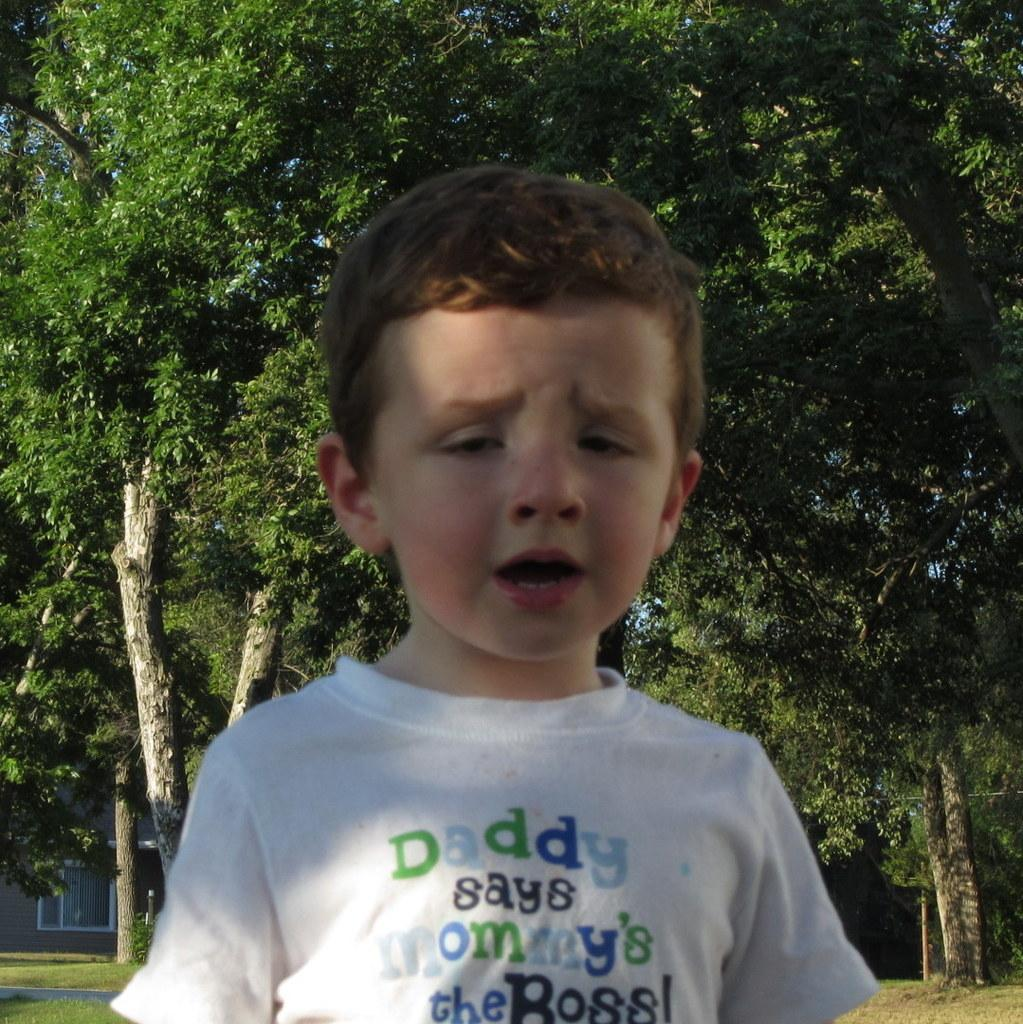What is the main subject in the foreground of the image? There is a boy in the foreground of the image. Where is the boy located? The boy is on the grass. What can be seen in the background of the image? There are trees and a house in the background of the image. What type of location might this image represent? The image may have been taken in a park, given the presence of grass and trees. Is the boy in the image participating in a war? There is no indication of war or any military activity in the image. The boy is simply on the grass in a park-like setting. 